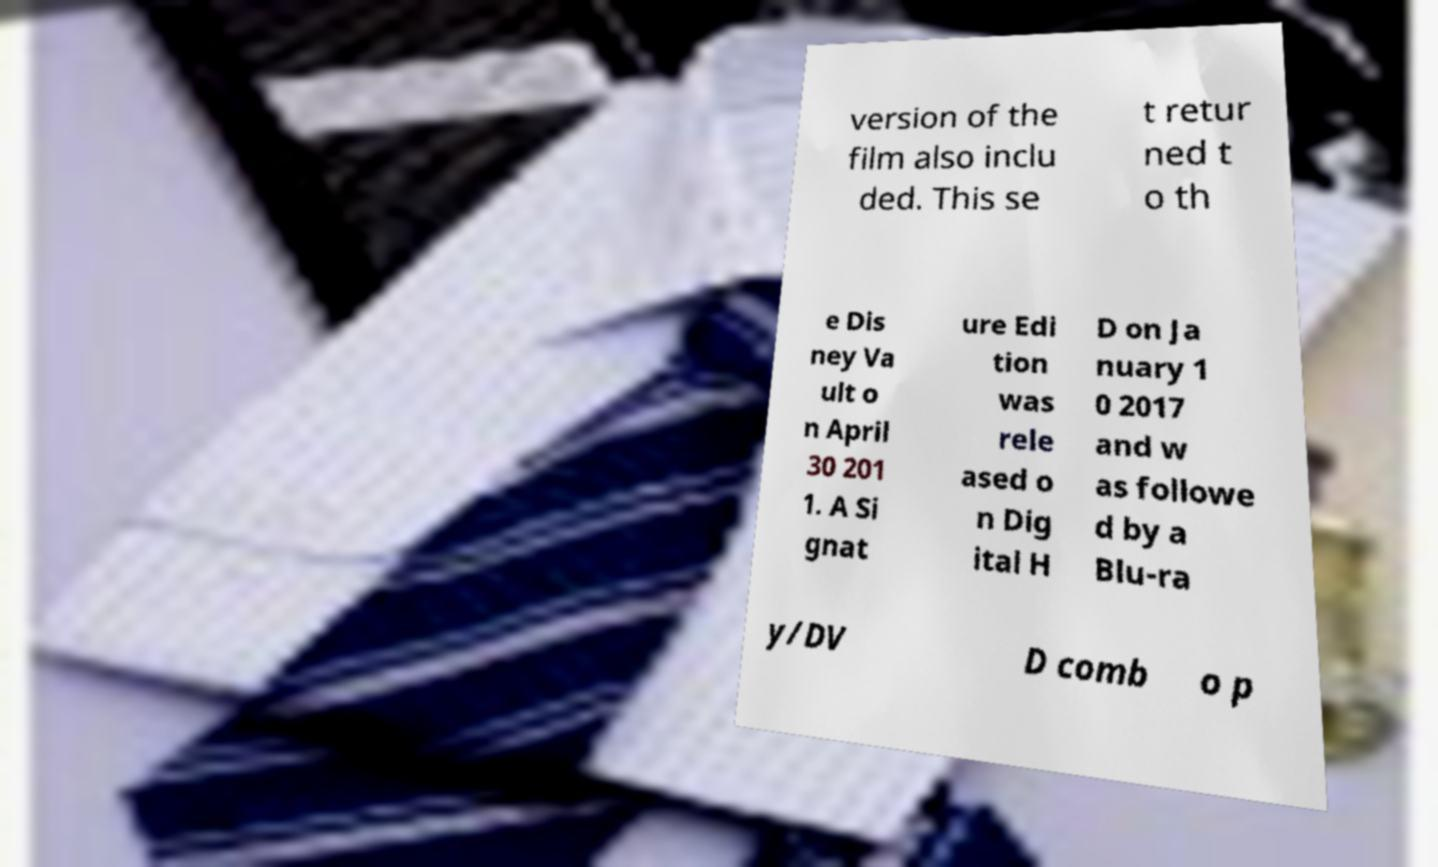Could you extract and type out the text from this image? version of the film also inclu ded. This se t retur ned t o th e Dis ney Va ult o n April 30 201 1. A Si gnat ure Edi tion was rele ased o n Dig ital H D on Ja nuary 1 0 2017 and w as followe d by a Blu-ra y/DV D comb o p 